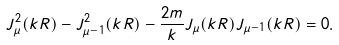<formula> <loc_0><loc_0><loc_500><loc_500>J _ { \mu } ^ { 2 } ( k R ) - J _ { \mu - 1 } ^ { 2 } ( k R ) - \frac { 2 m } { k } J _ { \mu } ( k R ) J _ { \mu - 1 } ( k R ) = 0 .</formula> 